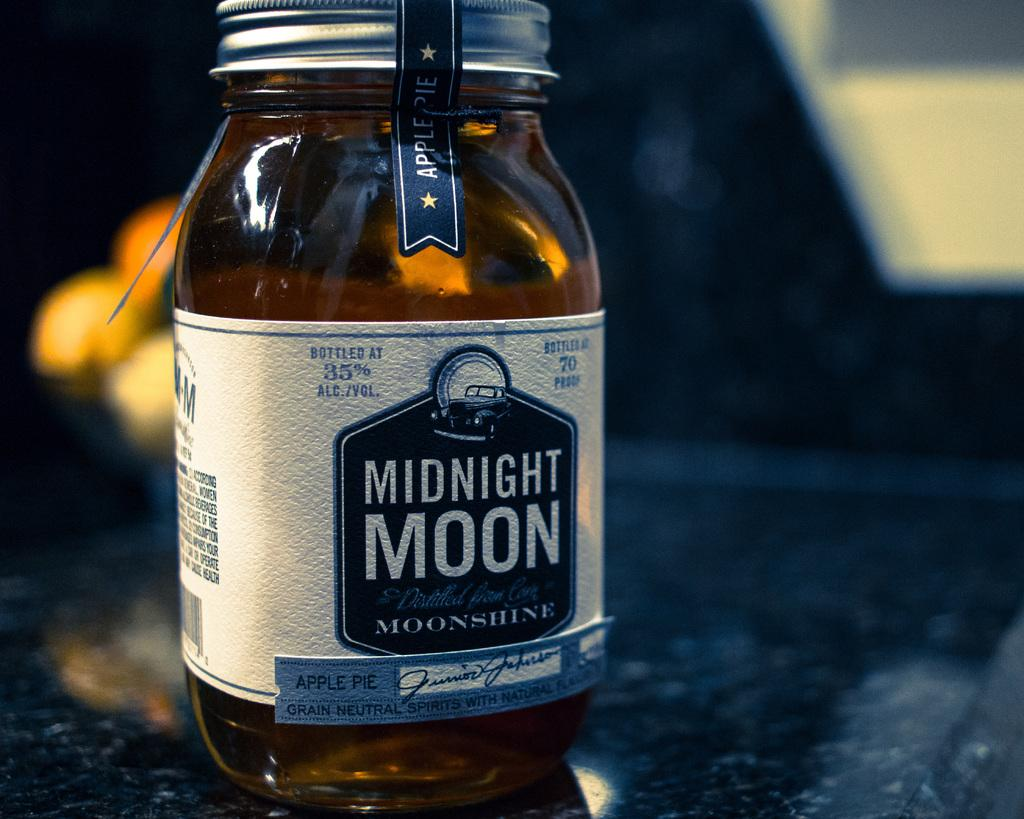Provide a one-sentence caption for the provided image. A jar has a label with blue and white text that reads, "Midnight Moon.". 